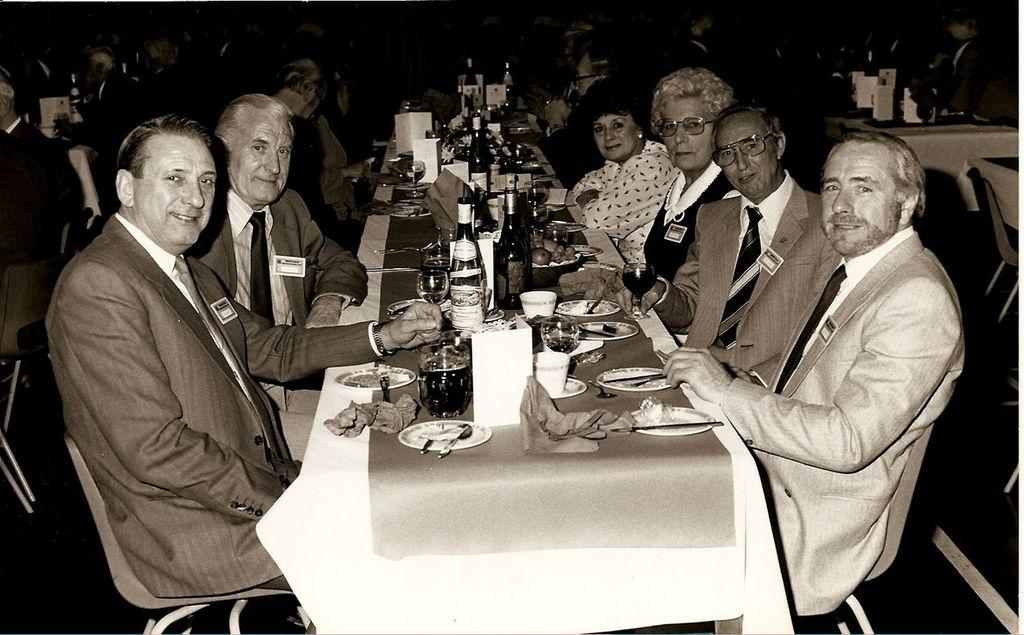What are the people in the image doing? There is a group of people sitting on chairs in the image. What objects can be seen on the table in the image? There is a plate, a spoon, tissue, a glass, a bottle, fruits, and food material on the table in the image. What type of news can be seen on the plate in the image? There is no news present in the image; the plate is empty. Are there any dolls visible on the table in the image? There are no dolls present in the image; the objects on the table are a plate, a spoon, tissue, a glass, a bottle, fruits, and food material. 